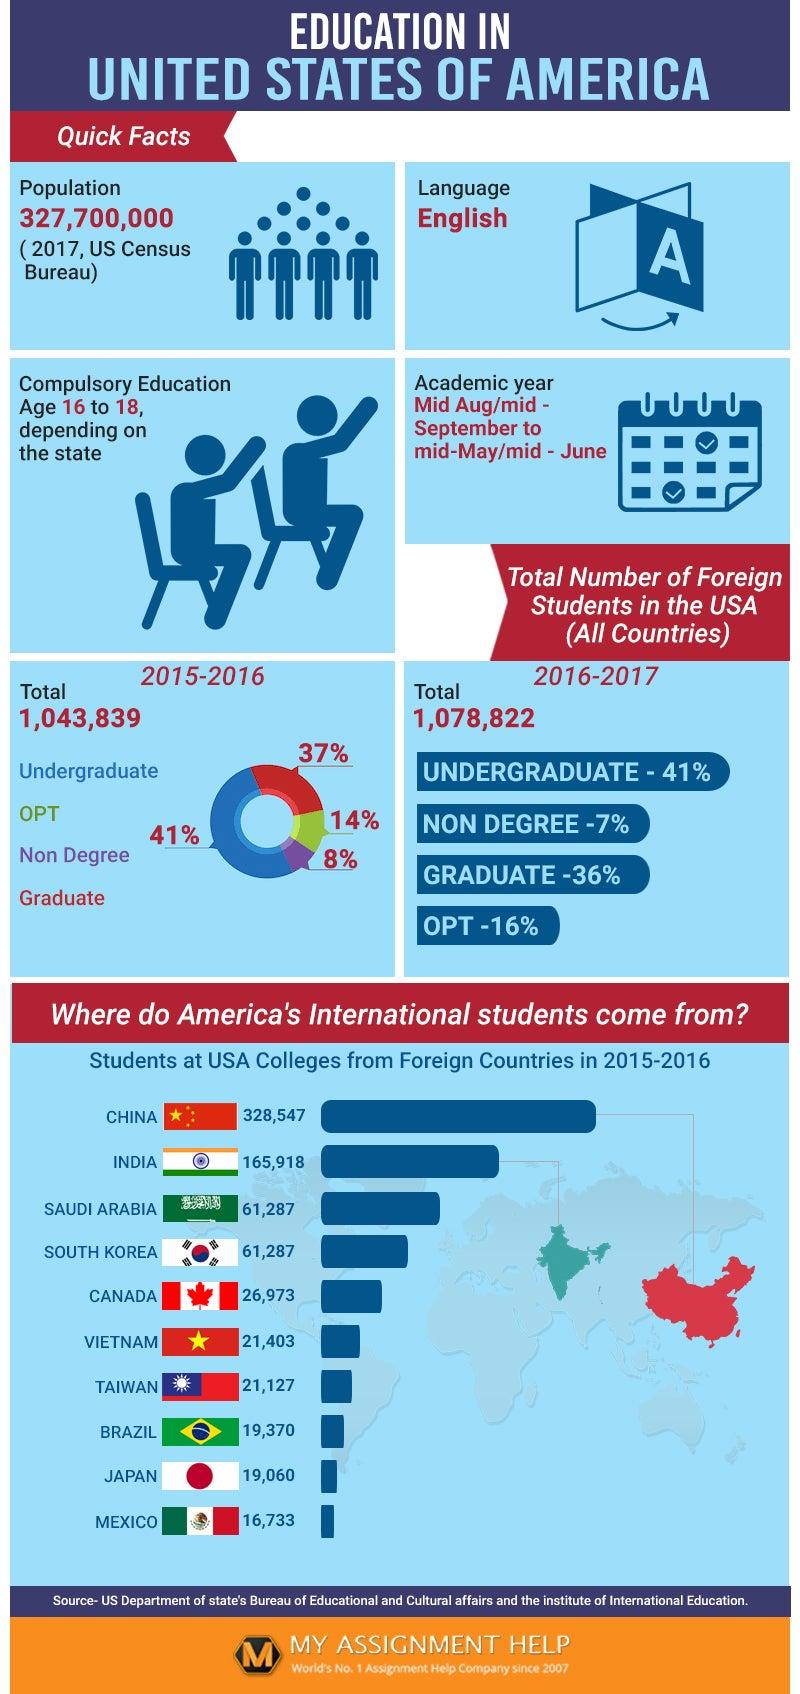Mention a couple of crucial points in this snapshot. The flag of Vietnam has only one star, while the flag of China has five stars. Therefore, Vietnam's flag has only one star. The percentage of decrease in foreign graduate students in the USA from the academic year 2015-2016 to 2016-2017 was 20.7%. The percentage of increase in the number of foreign OPT students in the given two academic years is X%. The academic year calendar displays either 2 or 3 tick marks, with 2 being the most common. The percentage of foreign students in the USA remained stable in both the academic years 2015-2016 and 2017-2018, with the majority of these students being undergraduate students. 